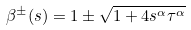Convert formula to latex. <formula><loc_0><loc_0><loc_500><loc_500>\beta ^ { \pm } ( s ) = 1 \pm \sqrt { 1 + 4 s ^ { \alpha } \tau ^ { \alpha } }</formula> 